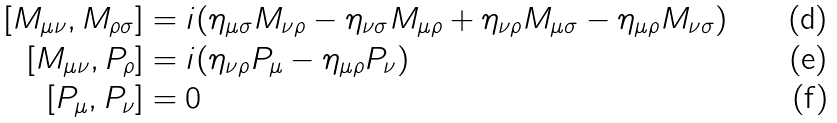<formula> <loc_0><loc_0><loc_500><loc_500>[ M _ { \mu \nu } , M _ { \rho \sigma } ] & = i ( \eta _ { \mu \sigma } M _ { \nu \rho } - \eta _ { \nu \sigma } M _ { \mu \rho } + \eta _ { \nu \rho } M _ { \mu \sigma } - \eta _ { \mu \rho } M _ { \nu \sigma } ) \\ [ M _ { \mu \nu } , P _ { \rho } ] & = i ( \eta _ { \nu \rho } P _ { \mu } - \eta _ { \mu \rho } P _ { \nu } ) \\ [ P _ { \mu } , P _ { \nu } ] & = 0</formula> 